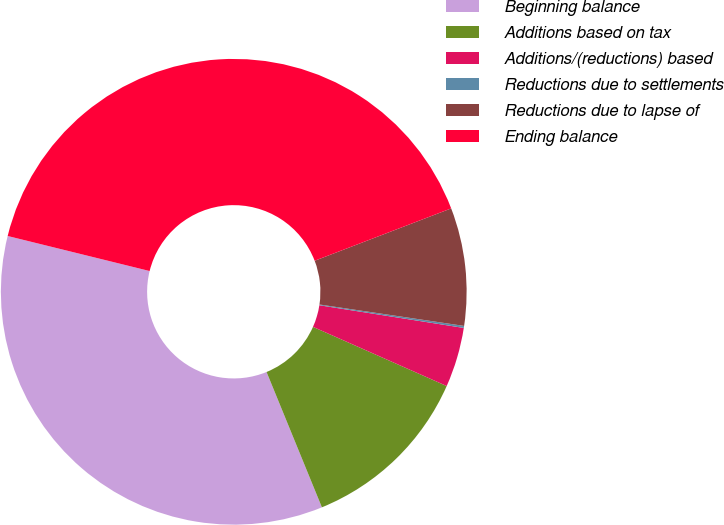<chart> <loc_0><loc_0><loc_500><loc_500><pie_chart><fcel>Beginning balance<fcel>Additions based on tax<fcel>Additions/(reductions) based<fcel>Reductions due to settlements<fcel>Reductions due to lapse of<fcel>Ending balance<nl><fcel>35.03%<fcel>12.19%<fcel>4.15%<fcel>0.14%<fcel>8.17%<fcel>40.32%<nl></chart> 